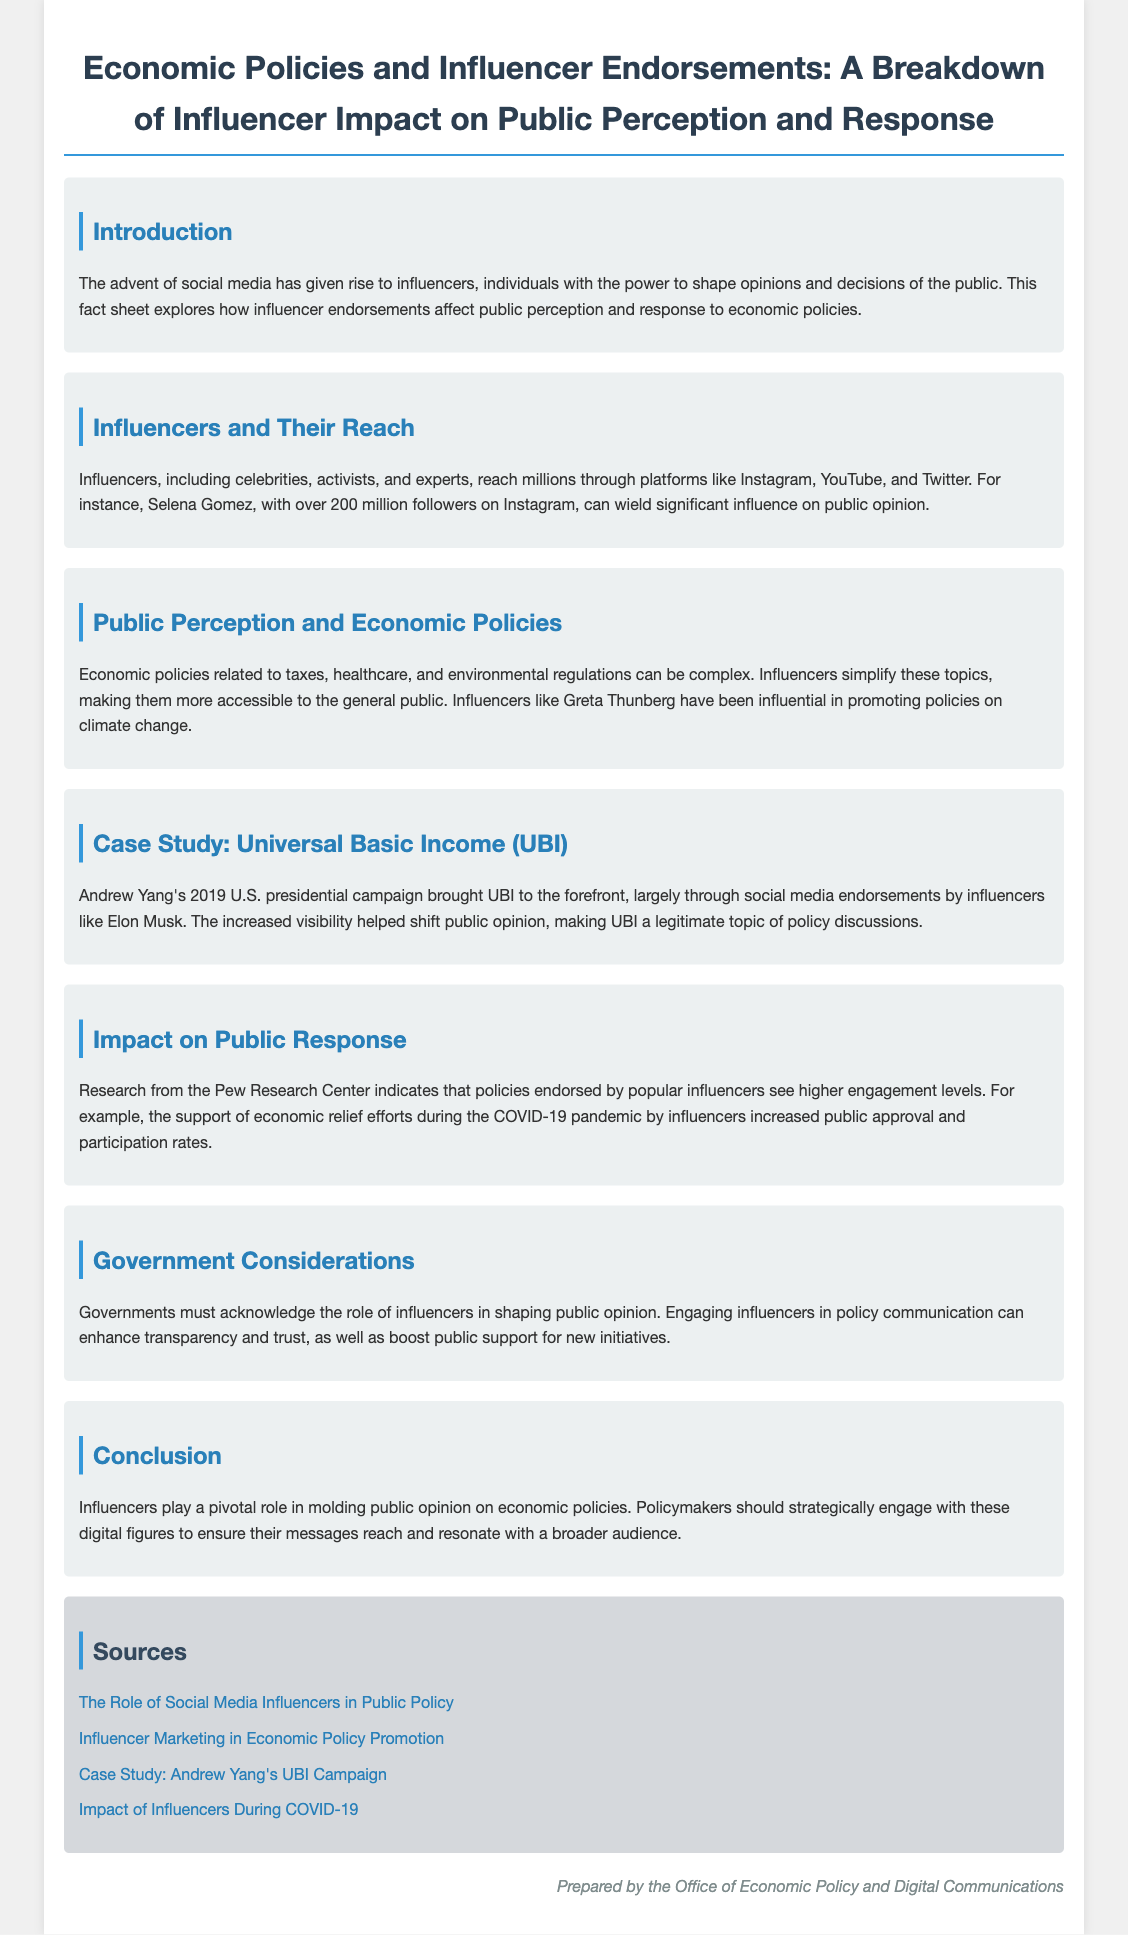What is the title of the document? The title is presented prominently at the top of the document.
Answer: Economic Policies and Influencer Endorsements: A Breakdown of Influencer Impact on Public Perception and Response Who is mentioned as having over 200 million followers on Instagram? The document mentions a specific influencer with a large following as an example.
Answer: Selena Gomez What economic policy was brought to the forefront by Andrew Yang's campaign? The document specifically mentions this policy as a case study in public opinion.
Answer: Universal Basic Income (UBI) Which influencer is noted for promoting climate change policies? This influencer is highlighted in the context of making economic policies more accessible.
Answer: Greta Thunberg What organization provided research information referenced in the document? The source of the research is clearly stated in the document.
Answer: Pew Research Center How do influencer endorsements impact public engagement, according to the document? This is explained in the section related to public response, indicating the effect of endorsements.
Answer: Increased engagement levels What role do influencers play in shaping economic policy communication? This question seeks to summarize the government's perspective on influencer involvement.
Answer: Enhancing transparency and trust What is one of the recommendations for governments mentioned in the document? The document includes a specific suggestion regarding engagement with influencers.
Answer: Engage influencers in policy communication 